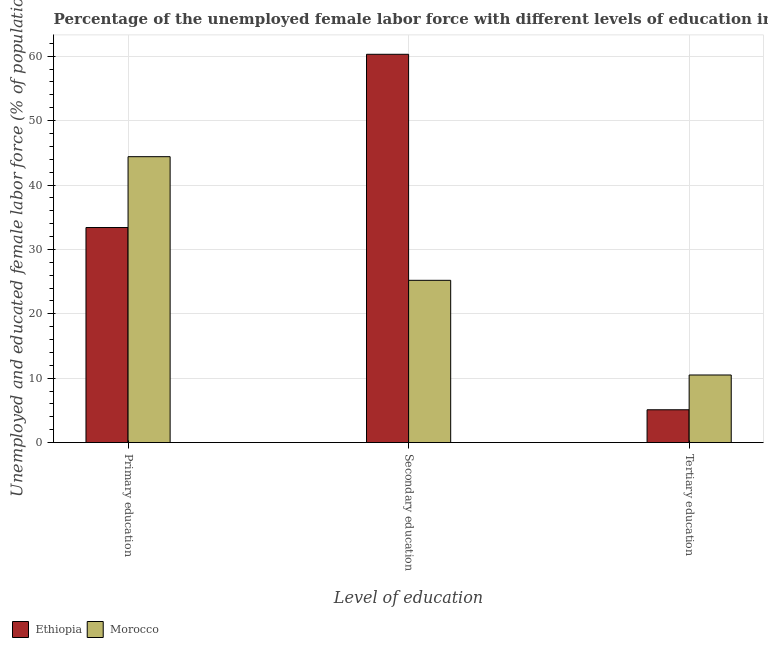How many groups of bars are there?
Give a very brief answer. 3. Are the number of bars per tick equal to the number of legend labels?
Your response must be concise. Yes. What is the label of the 2nd group of bars from the left?
Offer a very short reply. Secondary education. What is the percentage of female labor force who received tertiary education in Ethiopia?
Make the answer very short. 5.1. Across all countries, what is the maximum percentage of female labor force who received tertiary education?
Give a very brief answer. 10.5. Across all countries, what is the minimum percentage of female labor force who received tertiary education?
Provide a succinct answer. 5.1. In which country was the percentage of female labor force who received secondary education maximum?
Provide a succinct answer. Ethiopia. In which country was the percentage of female labor force who received secondary education minimum?
Provide a succinct answer. Morocco. What is the total percentage of female labor force who received secondary education in the graph?
Give a very brief answer. 85.5. What is the difference between the percentage of female labor force who received primary education in Morocco and that in Ethiopia?
Give a very brief answer. 11. What is the difference between the percentage of female labor force who received tertiary education in Ethiopia and the percentage of female labor force who received primary education in Morocco?
Your answer should be very brief. -39.3. What is the average percentage of female labor force who received secondary education per country?
Ensure brevity in your answer.  42.75. What is the difference between the percentage of female labor force who received primary education and percentage of female labor force who received tertiary education in Morocco?
Your answer should be compact. 33.9. What is the ratio of the percentage of female labor force who received primary education in Ethiopia to that in Morocco?
Your answer should be compact. 0.75. Is the difference between the percentage of female labor force who received secondary education in Morocco and Ethiopia greater than the difference between the percentage of female labor force who received tertiary education in Morocco and Ethiopia?
Provide a succinct answer. No. What is the difference between the highest and the second highest percentage of female labor force who received tertiary education?
Offer a terse response. 5.4. What is the difference between the highest and the lowest percentage of female labor force who received tertiary education?
Provide a short and direct response. 5.4. Is the sum of the percentage of female labor force who received primary education in Morocco and Ethiopia greater than the maximum percentage of female labor force who received secondary education across all countries?
Provide a short and direct response. Yes. What does the 1st bar from the left in Secondary education represents?
Your answer should be very brief. Ethiopia. What does the 1st bar from the right in Primary education represents?
Your answer should be compact. Morocco. Is it the case that in every country, the sum of the percentage of female labor force who received primary education and percentage of female labor force who received secondary education is greater than the percentage of female labor force who received tertiary education?
Offer a very short reply. Yes. How many countries are there in the graph?
Your response must be concise. 2. Does the graph contain grids?
Your response must be concise. Yes. What is the title of the graph?
Your response must be concise. Percentage of the unemployed female labor force with different levels of education in countries. What is the label or title of the X-axis?
Your answer should be very brief. Level of education. What is the label or title of the Y-axis?
Provide a short and direct response. Unemployed and educated female labor force (% of population). What is the Unemployed and educated female labor force (% of population) of Ethiopia in Primary education?
Your answer should be compact. 33.4. What is the Unemployed and educated female labor force (% of population) in Morocco in Primary education?
Your answer should be compact. 44.4. What is the Unemployed and educated female labor force (% of population) of Ethiopia in Secondary education?
Give a very brief answer. 60.3. What is the Unemployed and educated female labor force (% of population) in Morocco in Secondary education?
Give a very brief answer. 25.2. What is the Unemployed and educated female labor force (% of population) in Ethiopia in Tertiary education?
Provide a short and direct response. 5.1. What is the Unemployed and educated female labor force (% of population) of Morocco in Tertiary education?
Provide a short and direct response. 10.5. Across all Level of education, what is the maximum Unemployed and educated female labor force (% of population) of Ethiopia?
Provide a short and direct response. 60.3. Across all Level of education, what is the maximum Unemployed and educated female labor force (% of population) of Morocco?
Give a very brief answer. 44.4. Across all Level of education, what is the minimum Unemployed and educated female labor force (% of population) in Ethiopia?
Keep it short and to the point. 5.1. What is the total Unemployed and educated female labor force (% of population) of Ethiopia in the graph?
Your answer should be compact. 98.8. What is the total Unemployed and educated female labor force (% of population) in Morocco in the graph?
Provide a short and direct response. 80.1. What is the difference between the Unemployed and educated female labor force (% of population) of Ethiopia in Primary education and that in Secondary education?
Make the answer very short. -26.9. What is the difference between the Unemployed and educated female labor force (% of population) in Ethiopia in Primary education and that in Tertiary education?
Provide a short and direct response. 28.3. What is the difference between the Unemployed and educated female labor force (% of population) of Morocco in Primary education and that in Tertiary education?
Provide a short and direct response. 33.9. What is the difference between the Unemployed and educated female labor force (% of population) of Ethiopia in Secondary education and that in Tertiary education?
Your answer should be compact. 55.2. What is the difference between the Unemployed and educated female labor force (% of population) of Ethiopia in Primary education and the Unemployed and educated female labor force (% of population) of Morocco in Secondary education?
Offer a very short reply. 8.2. What is the difference between the Unemployed and educated female labor force (% of population) of Ethiopia in Primary education and the Unemployed and educated female labor force (% of population) of Morocco in Tertiary education?
Your response must be concise. 22.9. What is the difference between the Unemployed and educated female labor force (% of population) in Ethiopia in Secondary education and the Unemployed and educated female labor force (% of population) in Morocco in Tertiary education?
Your response must be concise. 49.8. What is the average Unemployed and educated female labor force (% of population) of Ethiopia per Level of education?
Provide a succinct answer. 32.93. What is the average Unemployed and educated female labor force (% of population) in Morocco per Level of education?
Ensure brevity in your answer.  26.7. What is the difference between the Unemployed and educated female labor force (% of population) of Ethiopia and Unemployed and educated female labor force (% of population) of Morocco in Secondary education?
Give a very brief answer. 35.1. What is the difference between the Unemployed and educated female labor force (% of population) of Ethiopia and Unemployed and educated female labor force (% of population) of Morocco in Tertiary education?
Make the answer very short. -5.4. What is the ratio of the Unemployed and educated female labor force (% of population) of Ethiopia in Primary education to that in Secondary education?
Make the answer very short. 0.55. What is the ratio of the Unemployed and educated female labor force (% of population) in Morocco in Primary education to that in Secondary education?
Your answer should be very brief. 1.76. What is the ratio of the Unemployed and educated female labor force (% of population) of Ethiopia in Primary education to that in Tertiary education?
Provide a succinct answer. 6.55. What is the ratio of the Unemployed and educated female labor force (% of population) of Morocco in Primary education to that in Tertiary education?
Provide a succinct answer. 4.23. What is the ratio of the Unemployed and educated female labor force (% of population) of Ethiopia in Secondary education to that in Tertiary education?
Your answer should be very brief. 11.82. What is the difference between the highest and the second highest Unemployed and educated female labor force (% of population) of Ethiopia?
Your answer should be very brief. 26.9. What is the difference between the highest and the second highest Unemployed and educated female labor force (% of population) in Morocco?
Offer a very short reply. 19.2. What is the difference between the highest and the lowest Unemployed and educated female labor force (% of population) of Ethiopia?
Provide a short and direct response. 55.2. What is the difference between the highest and the lowest Unemployed and educated female labor force (% of population) of Morocco?
Offer a terse response. 33.9. 